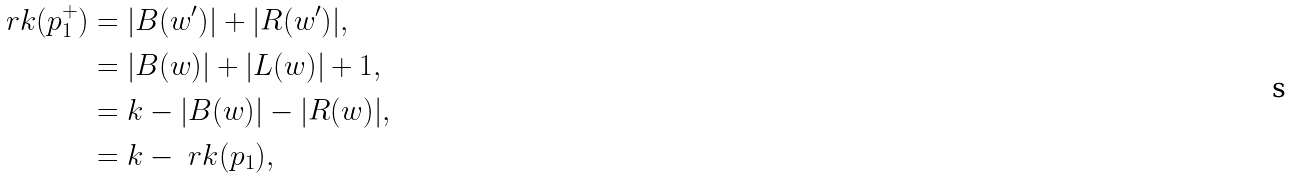Convert formula to latex. <formula><loc_0><loc_0><loc_500><loc_500>\ r k ( p _ { 1 } ^ { + } ) & = | B ( w ^ { \prime } ) | + | R ( w ^ { \prime } ) | , \\ & = | B ( w ) | + | L ( w ) | + 1 , \\ & = k - | B ( w ) | - | R ( w ) | , \\ & = k - \ r k ( p _ { 1 } ) ,</formula> 